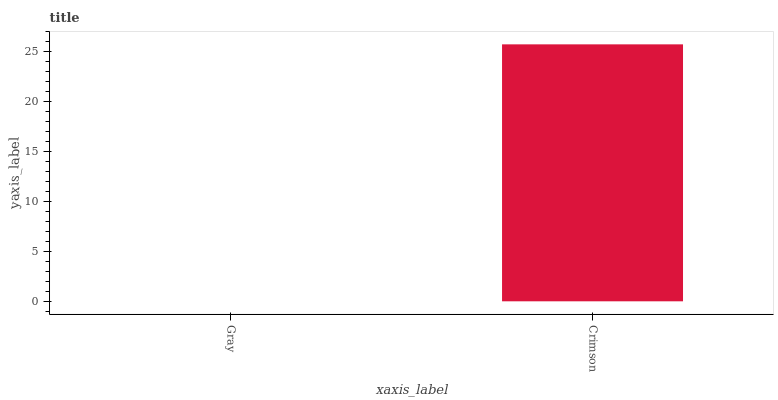Is Gray the minimum?
Answer yes or no. Yes. Is Crimson the maximum?
Answer yes or no. Yes. Is Crimson the minimum?
Answer yes or no. No. Is Crimson greater than Gray?
Answer yes or no. Yes. Is Gray less than Crimson?
Answer yes or no. Yes. Is Gray greater than Crimson?
Answer yes or no. No. Is Crimson less than Gray?
Answer yes or no. No. Is Crimson the high median?
Answer yes or no. Yes. Is Gray the low median?
Answer yes or no. Yes. Is Gray the high median?
Answer yes or no. No. Is Crimson the low median?
Answer yes or no. No. 